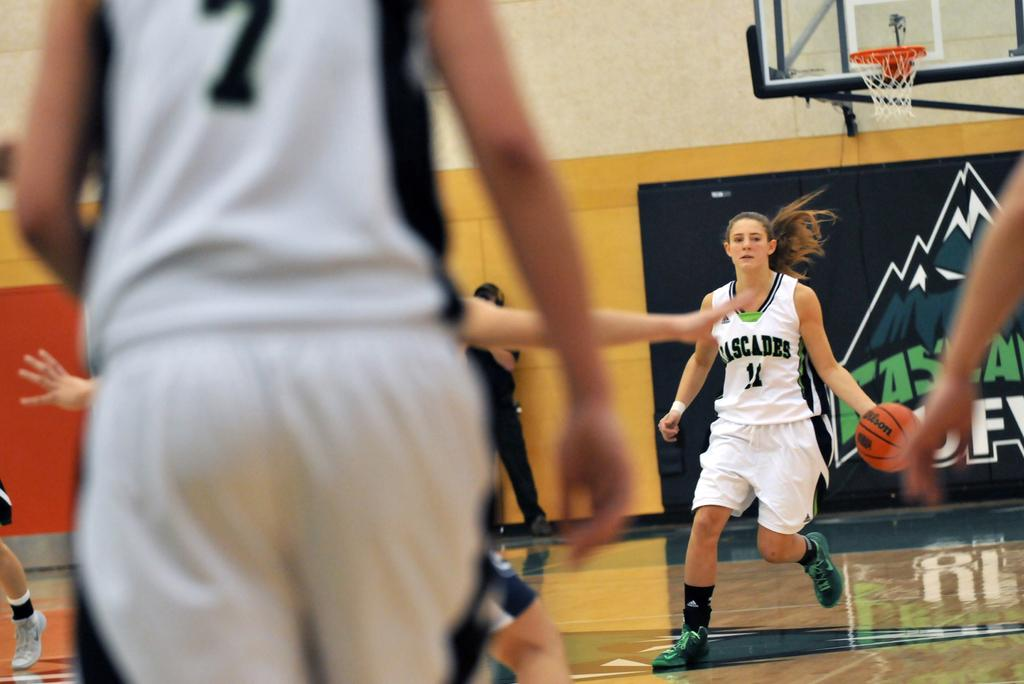<image>
Provide a brief description of the given image. A female basketball player depicting the number 7 on the back of her jersey faces a teammate that has possession of the basketball. 